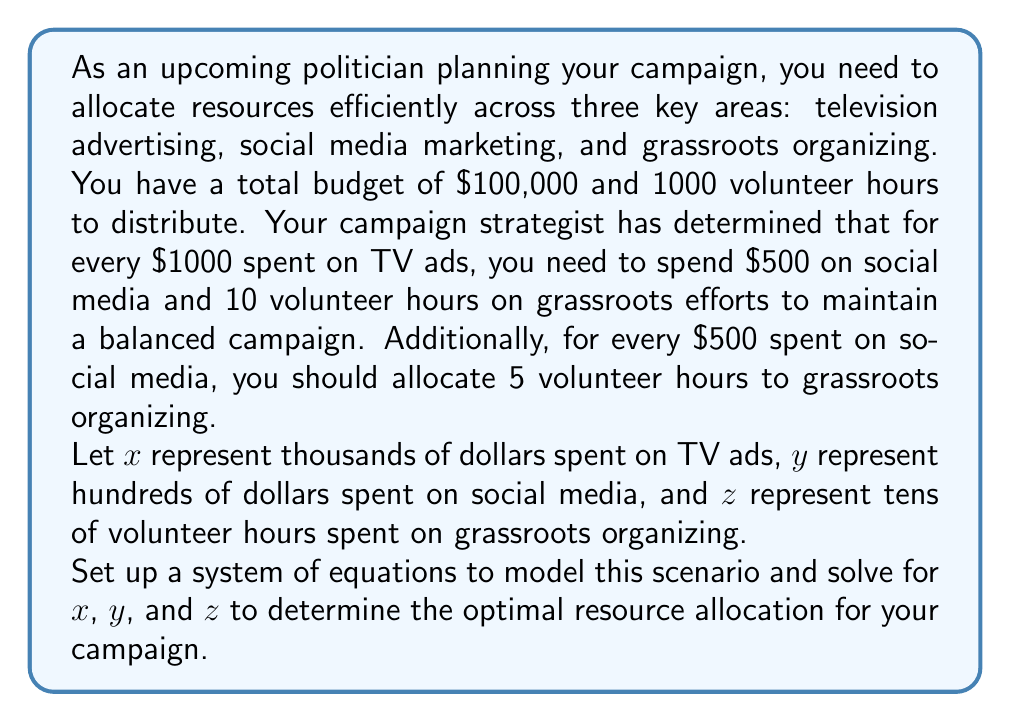Give your solution to this math problem. Let's approach this step-by-step:

1) First, we need to set up our system of equations based on the given information:

   Equation 1 (Budget constraint): 
   $$x + 0.5y = 100$$ 
   (since $x$ is in thousands and $y$ is in hundreds, we need to multiply $y$ by 0.5 to convert to thousands)

   Equation 2 (Volunteer hours constraint): 
   $$z = 100$$ 
   (since $z$ is in tens of hours, and we have 1000 total hours)

   Equation 3 (Relationship between TV ads and social media): 
   $$y = 0.5x$$

   Equation 4 (Relationship between TV ads and grassroots): 
   $$z = x$$

   Equation 5 (Relationship between social media and grassroots): 
   $$z = y$$

2) From equations 3 and 4, we can see that:
   $$x = z = 100$$

3) Substituting this into equation 3:
   $$y = 0.5(100) = 50$$

4) Let's verify if this satisfies our budget constraint (equation 1):
   $$100 + 0.5(50) = 100 + 25 = 125$$

   This exceeds our budget of $100,000, so we need to adjust our allocation.

5) Let's use equation 1 and 3 to solve for $x$:
   $$x + 0.5(0.5x) = 100$$
   $$x + 0.25x = 100$$
   $$1.25x = 100$$
   $$x = 80$$

6) Now we can solve for $y$ and $z$:
   $$y = 0.5(80) = 40$$
   $$z = 80$$

7) Let's verify our budget constraint:
   $$80 + 0.5(40) = 80 + 20 = 100$$
   This satisfies our $100,000 budget.

8) And our volunteer hours:
   $$80 * 10 = 800$$ hours, which is less than our 1000 hour limit.

Therefore, the optimal allocation is:
$x = 80$ (thousand dollars on TV ads)
$y = 40$ (hundred dollars on social media)
$z = 80$ (tens of volunteer hours on grassroots)
Answer: The optimal resource allocation for the campaign is:
$80,000 on television advertising
$4,000 on social media marketing
800 volunteer hours on grassroots organizing 